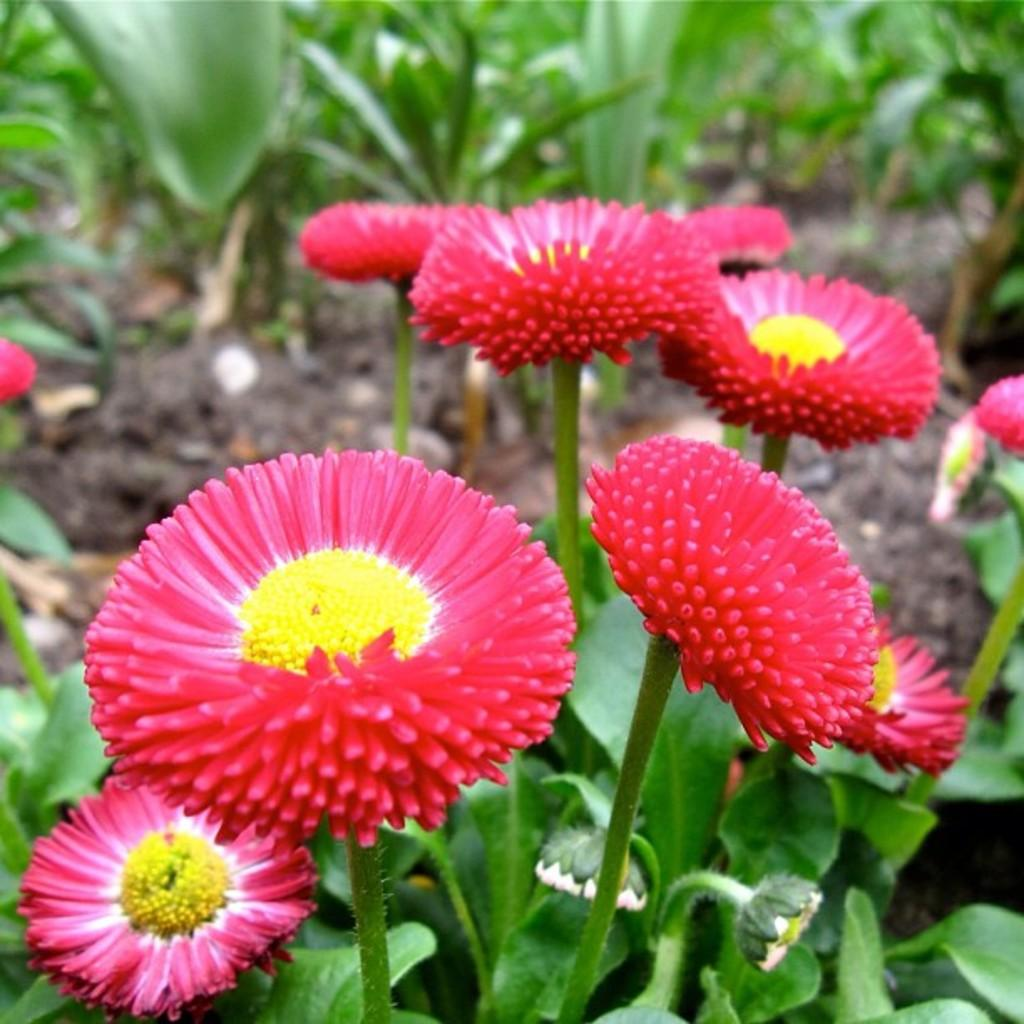What colors are the flowers in the image? The flowers in the image are red and yellow. What color are the plants on the ground in the image? The plants on the ground in the image are green. Where can I find the ticket for the event in the image? There is no ticket or event present in the image; it features flowers and plants. Can you tell me how much the payment for the picture is? There is no payment or picture present in the image; it features flowers and plants. 